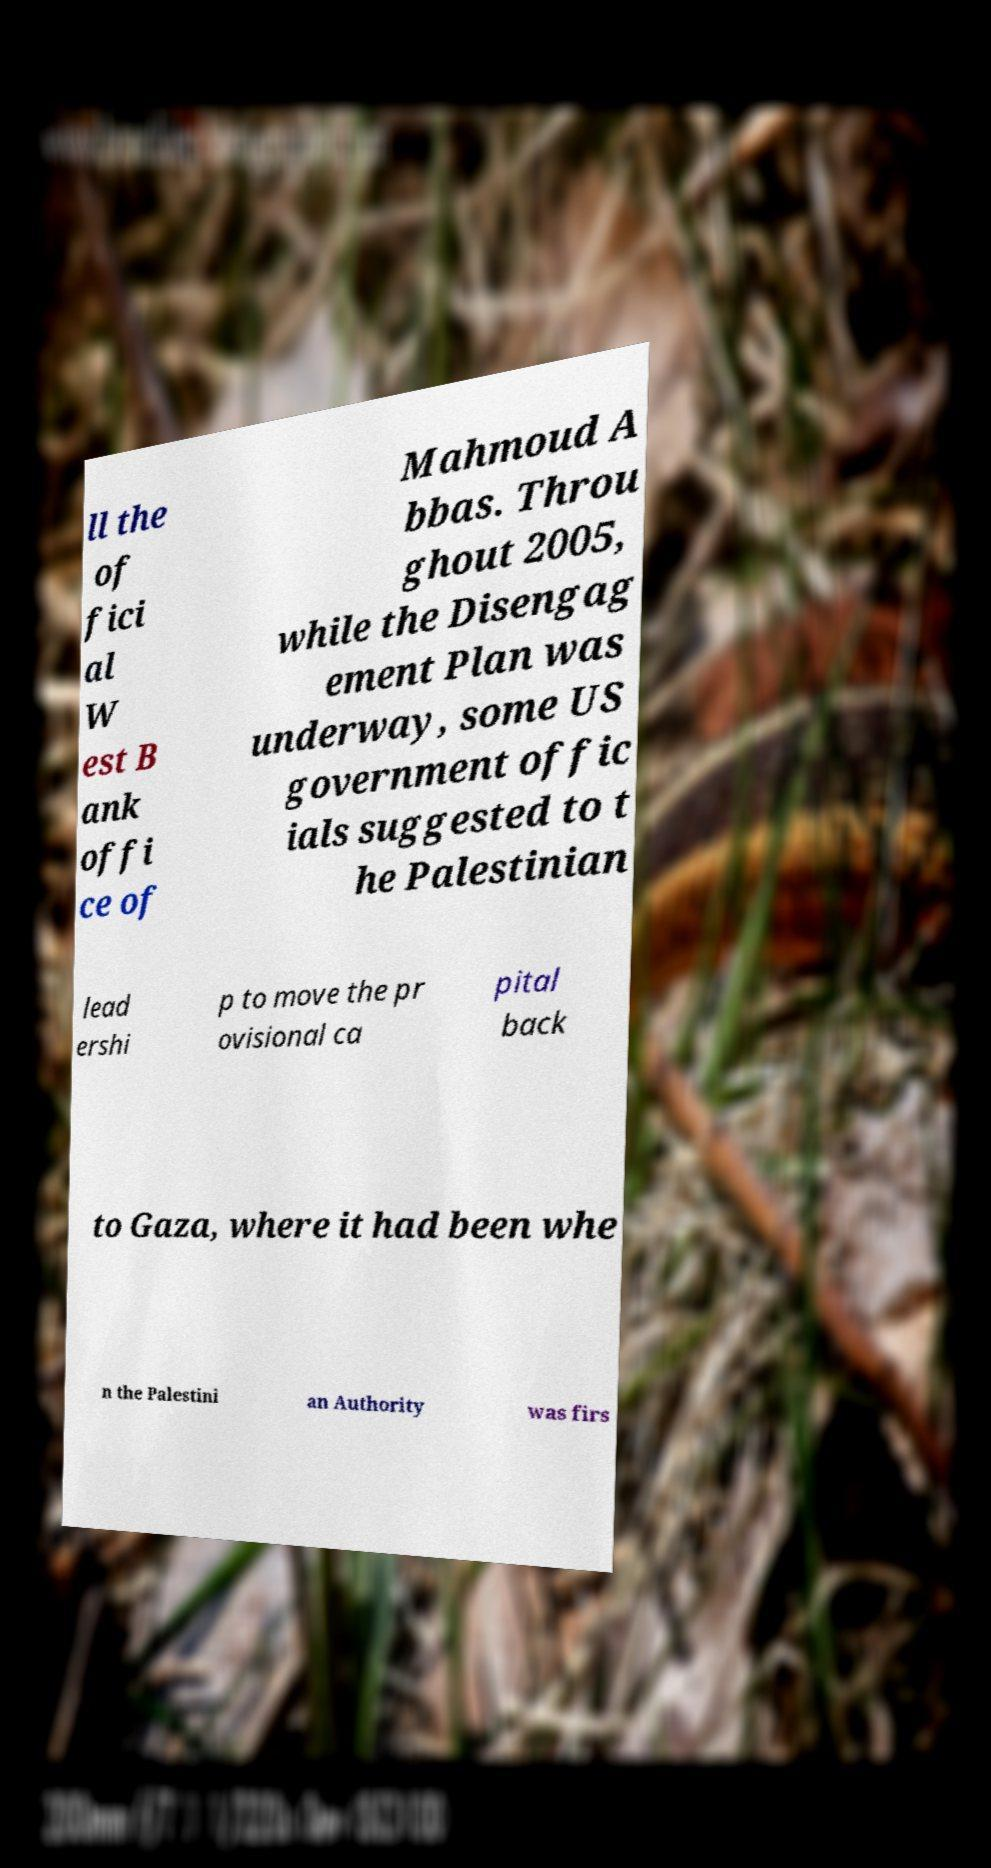Please identify and transcribe the text found in this image. ll the of fici al W est B ank offi ce of Mahmoud A bbas. Throu ghout 2005, while the Disengag ement Plan was underway, some US government offic ials suggested to t he Palestinian lead ershi p to move the pr ovisional ca pital back to Gaza, where it had been whe n the Palestini an Authority was firs 